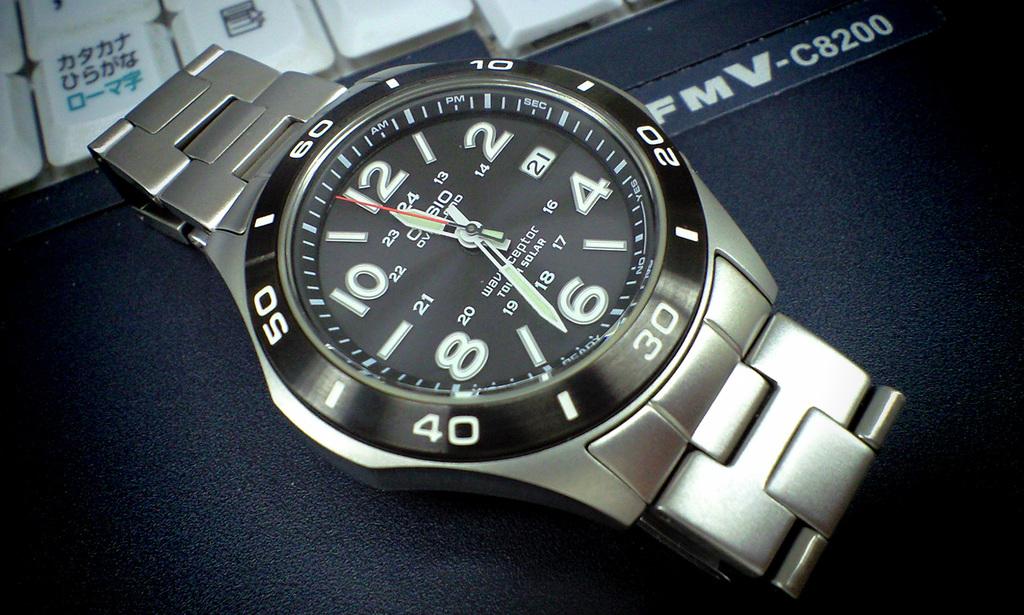About what time is it?
Offer a terse response. 11:33. 